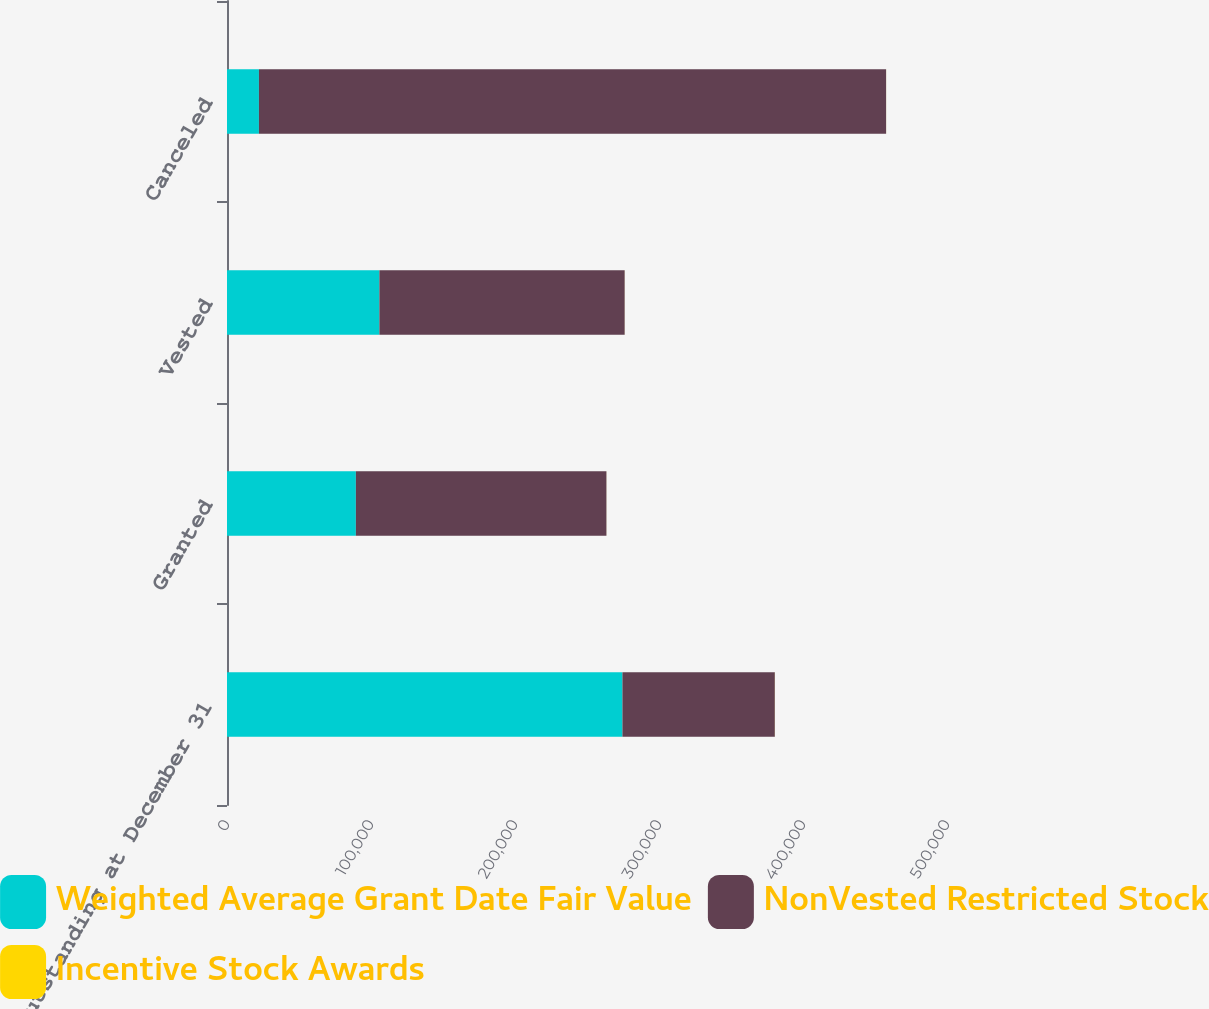Convert chart to OTSL. <chart><loc_0><loc_0><loc_500><loc_500><stacked_bar_chart><ecel><fcel>Outstanding at December 31<fcel>Granted<fcel>Vested<fcel>Canceled<nl><fcel>Weighted Average Grant Date Fair Value<fcel>274609<fcel>89500<fcel>105833<fcel>22175<nl><fcel>NonVested Restricted Stock<fcel>105833<fcel>174000<fcel>170334<fcel>435540<nl><fcel>Incentive Stock Awards<fcel>44.04<fcel>29<fcel>36.39<fcel>34.7<nl></chart> 